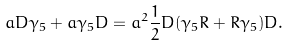<formula> <loc_0><loc_0><loc_500><loc_500>a D \gamma _ { 5 } + a \gamma _ { 5 } D = a ^ { 2 } \frac { 1 } { 2 } D ( \gamma _ { 5 } R + R \gamma _ { 5 } ) D .</formula> 